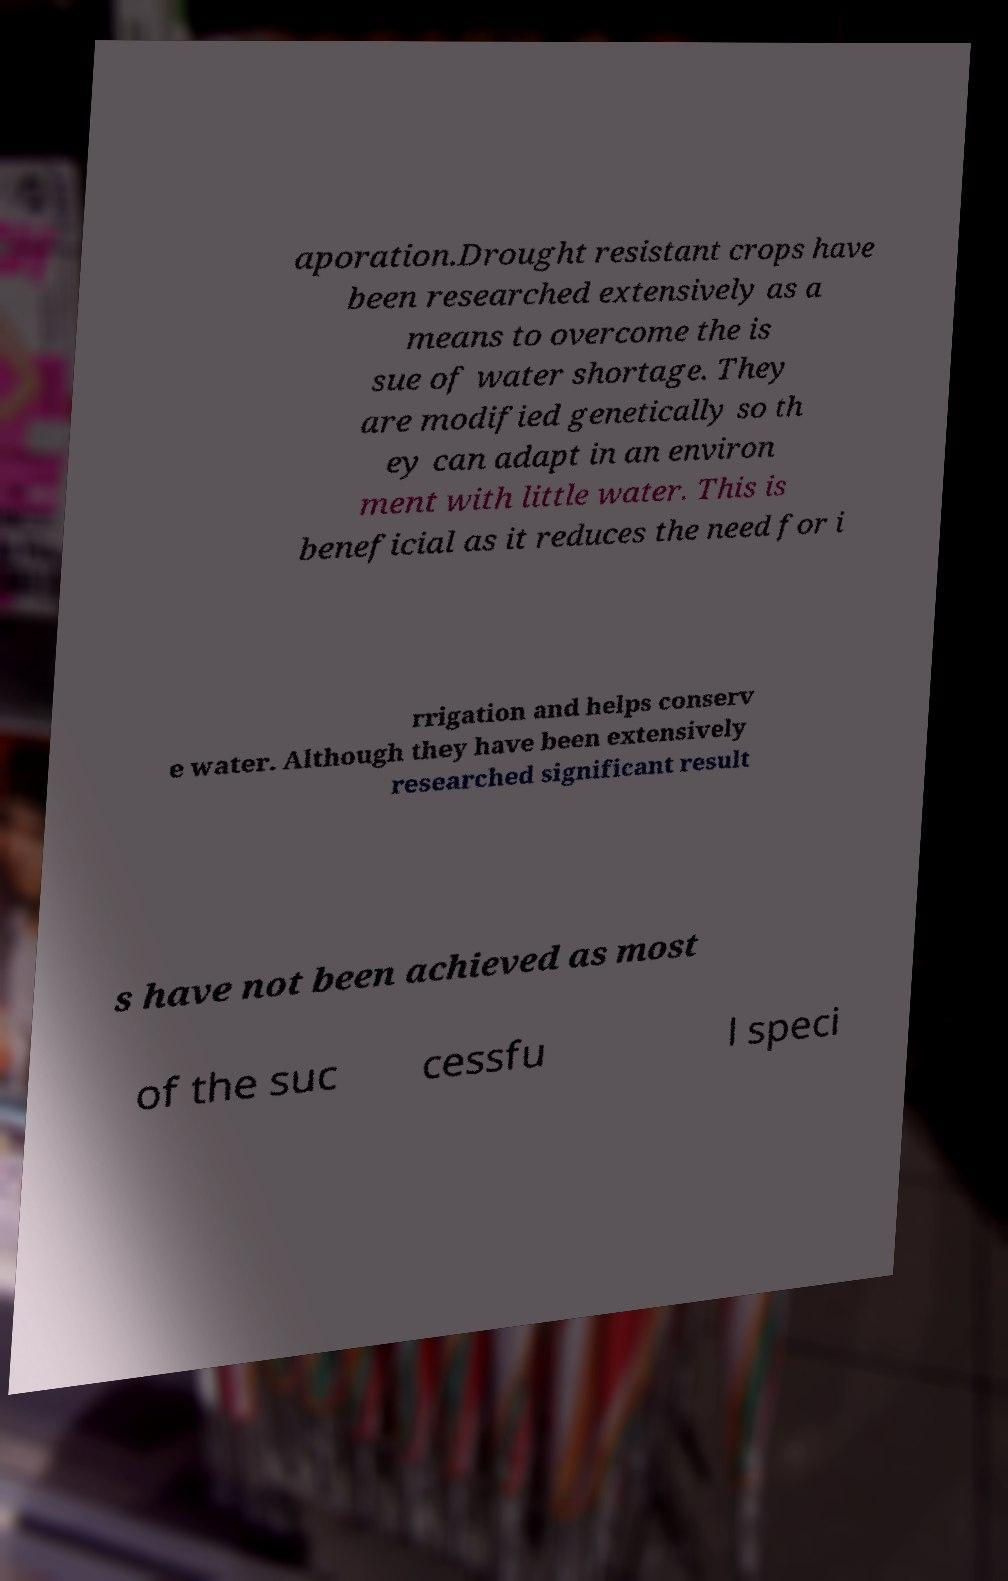What messages or text are displayed in this image? I need them in a readable, typed format. aporation.Drought resistant crops have been researched extensively as a means to overcome the is sue of water shortage. They are modified genetically so th ey can adapt in an environ ment with little water. This is beneficial as it reduces the need for i rrigation and helps conserv e water. Although they have been extensively researched significant result s have not been achieved as most of the suc cessfu l speci 